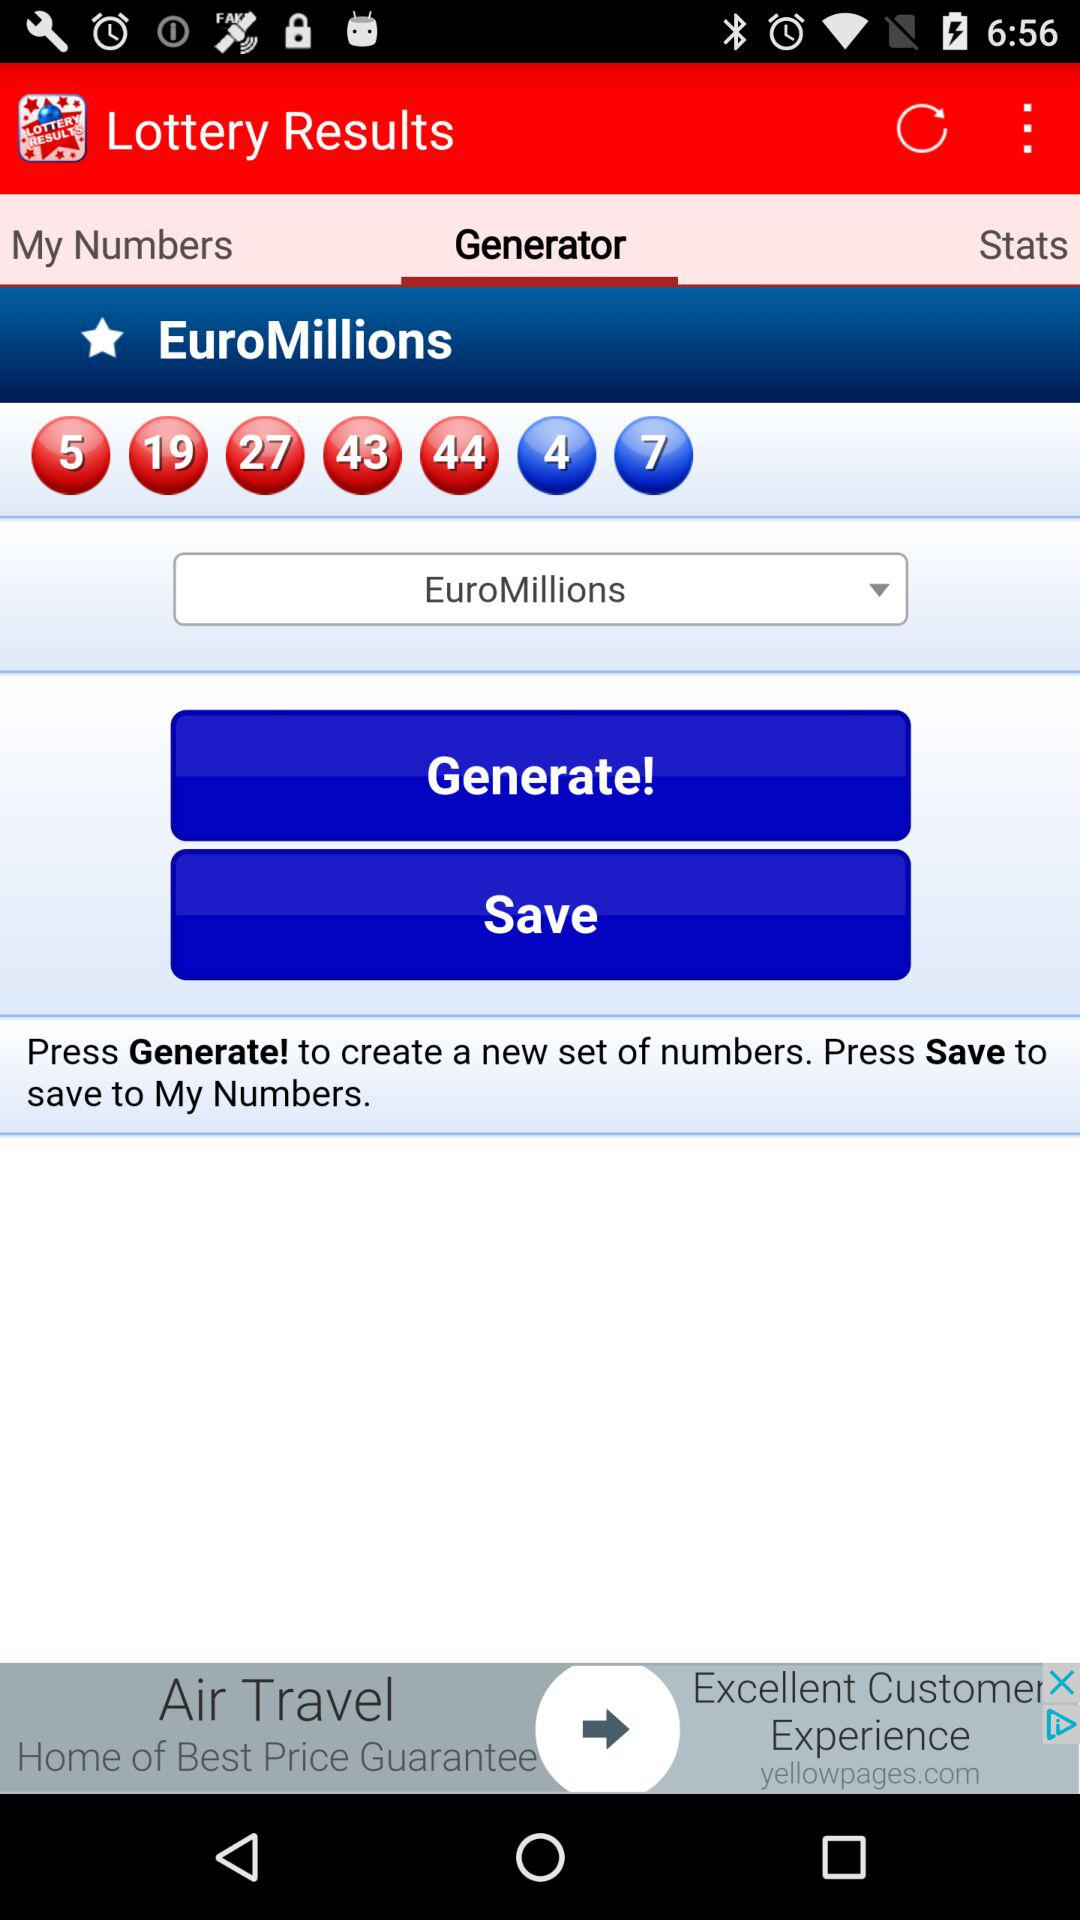Which tab is currently selected under Lottery Results? The selected tab is "Generator". 